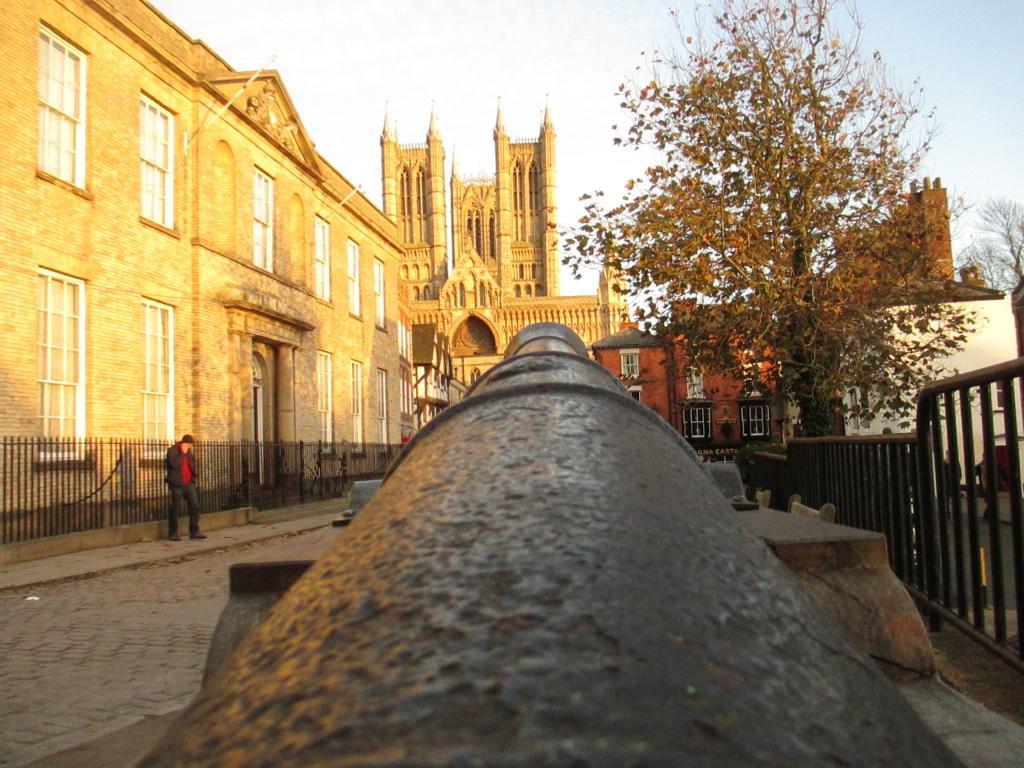In one or two sentences, can you explain what this image depicts? In this picture, we can see an object, a person, ground, trees, fencing, buildings, and the sky. 